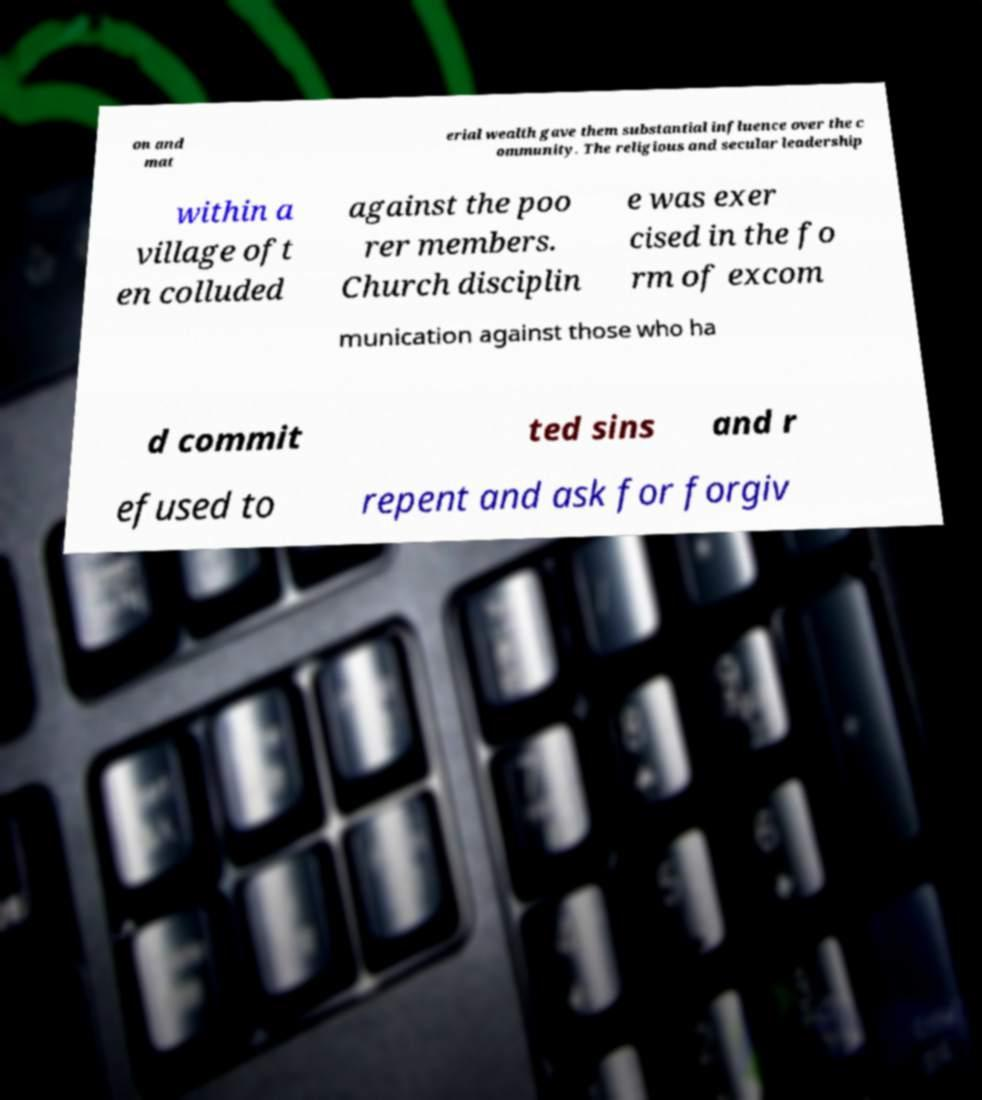What messages or text are displayed in this image? I need them in a readable, typed format. on and mat erial wealth gave them substantial influence over the c ommunity. The religious and secular leadership within a village oft en colluded against the poo rer members. Church disciplin e was exer cised in the fo rm of excom munication against those who ha d commit ted sins and r efused to repent and ask for forgiv 